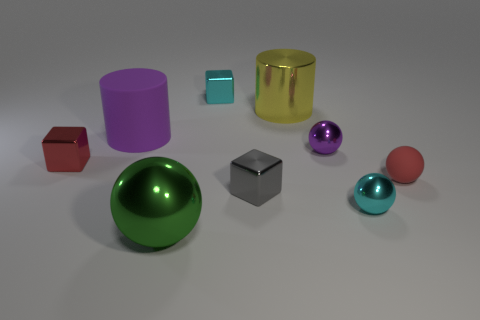Subtract all cyan shiny spheres. How many spheres are left? 3 Subtract all purple cylinders. How many cylinders are left? 1 Subtract 2 cubes. How many cubes are left? 1 Subtract all blocks. How many objects are left? 6 Subtract all yellow cylinders. Subtract all yellow blocks. How many cylinders are left? 1 Subtract all red cylinders. Subtract all big rubber objects. How many objects are left? 8 Add 3 red things. How many red things are left? 5 Add 5 large purple shiny things. How many large purple shiny things exist? 5 Subtract 0 purple cubes. How many objects are left? 9 